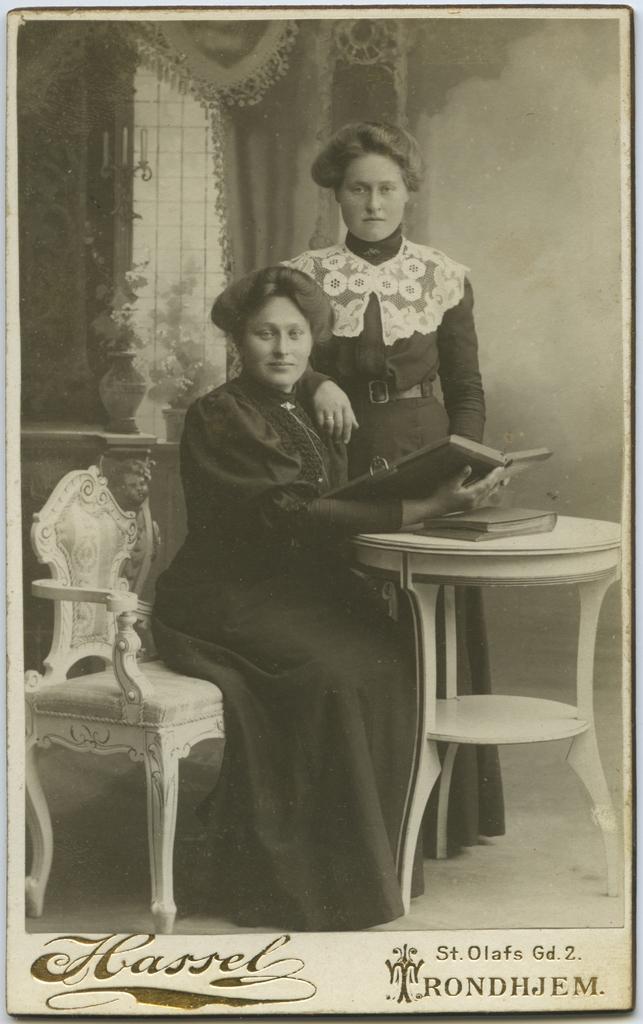Describe this image in one or two sentences. This is a picture of a black and white photo , where there is a person sitting and holding a book, another person standing , a book on the table, chair, flower vases, candles,curtain, and there are words, number and a symbol on the photo. 